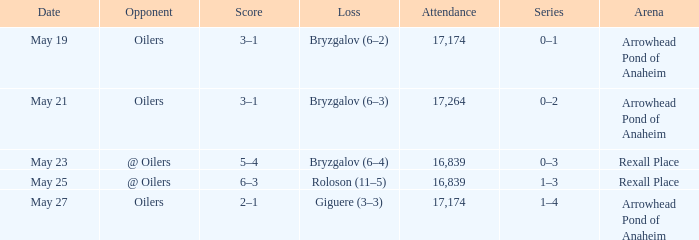Which attendance contains an arena of arrowhead pond of anaheim, and a loss of giguere (3-3)? 17174.0. 